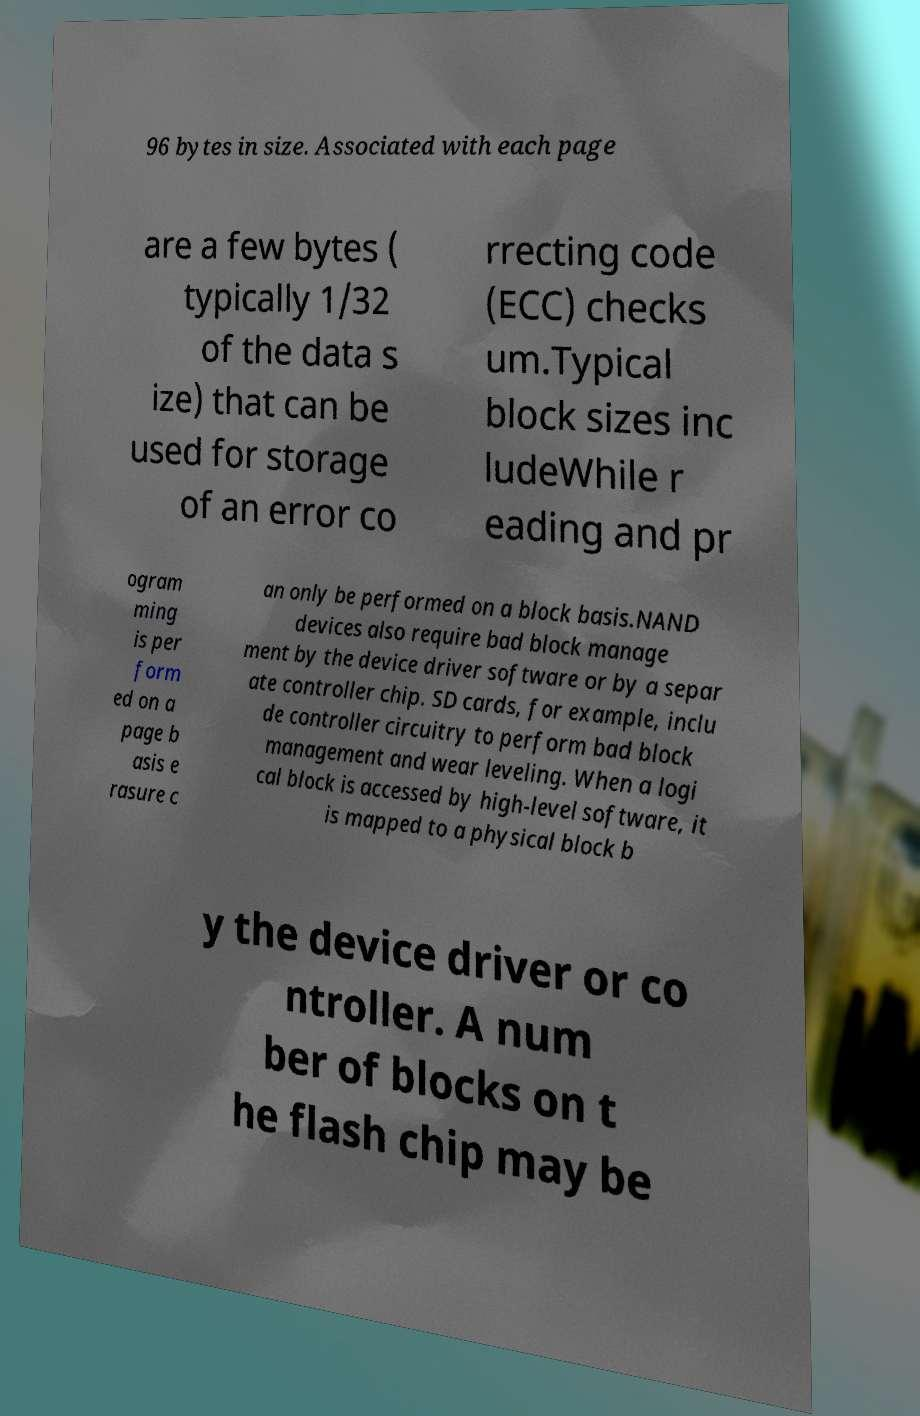Can you read and provide the text displayed in the image?This photo seems to have some interesting text. Can you extract and type it out for me? 96 bytes in size. Associated with each page are a few bytes ( typically 1/32 of the data s ize) that can be used for storage of an error co rrecting code (ECC) checks um.Typical block sizes inc ludeWhile r eading and pr ogram ming is per form ed on a page b asis e rasure c an only be performed on a block basis.NAND devices also require bad block manage ment by the device driver software or by a separ ate controller chip. SD cards, for example, inclu de controller circuitry to perform bad block management and wear leveling. When a logi cal block is accessed by high-level software, it is mapped to a physical block b y the device driver or co ntroller. A num ber of blocks on t he flash chip may be 